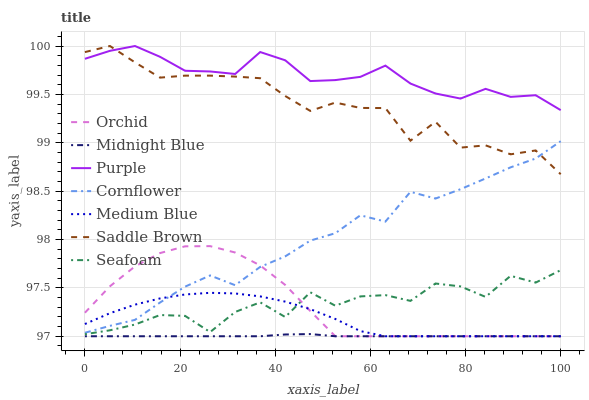Does Midnight Blue have the minimum area under the curve?
Answer yes or no. Yes. Does Purple have the maximum area under the curve?
Answer yes or no. Yes. Does Purple have the minimum area under the curve?
Answer yes or no. No. Does Midnight Blue have the maximum area under the curve?
Answer yes or no. No. Is Midnight Blue the smoothest?
Answer yes or no. Yes. Is Seafoam the roughest?
Answer yes or no. Yes. Is Purple the smoothest?
Answer yes or no. No. Is Purple the roughest?
Answer yes or no. No. Does Purple have the lowest value?
Answer yes or no. No. Does Saddle Brown have the highest value?
Answer yes or no. Yes. Does Midnight Blue have the highest value?
Answer yes or no. No. Is Midnight Blue less than Seafoam?
Answer yes or no. Yes. Is Purple greater than Medium Blue?
Answer yes or no. Yes. Does Midnight Blue intersect Seafoam?
Answer yes or no. No. 